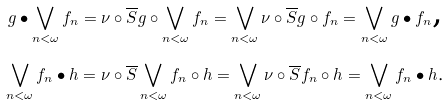<formula> <loc_0><loc_0><loc_500><loc_500>g \bullet \bigvee _ { n < \omega } f _ { n } = \nu \circ \overline { S } g \circ \bigvee _ { n < \omega } f _ { n } = \bigvee _ { n < \omega } \nu \circ \overline { S } g \circ f _ { n } = \bigvee _ { n < \omega } g \bullet f _ { n } \text {,} \\ \bigvee _ { n < \omega } f _ { n } \bullet h = \nu \circ \overline { S } \bigvee _ { n < \omega } f _ { n } \circ h = \bigvee _ { n < \omega } \nu \circ \overline { S } f _ { n } \circ h = \bigvee _ { n < \omega } f _ { n } \bullet h \text {.}</formula> 